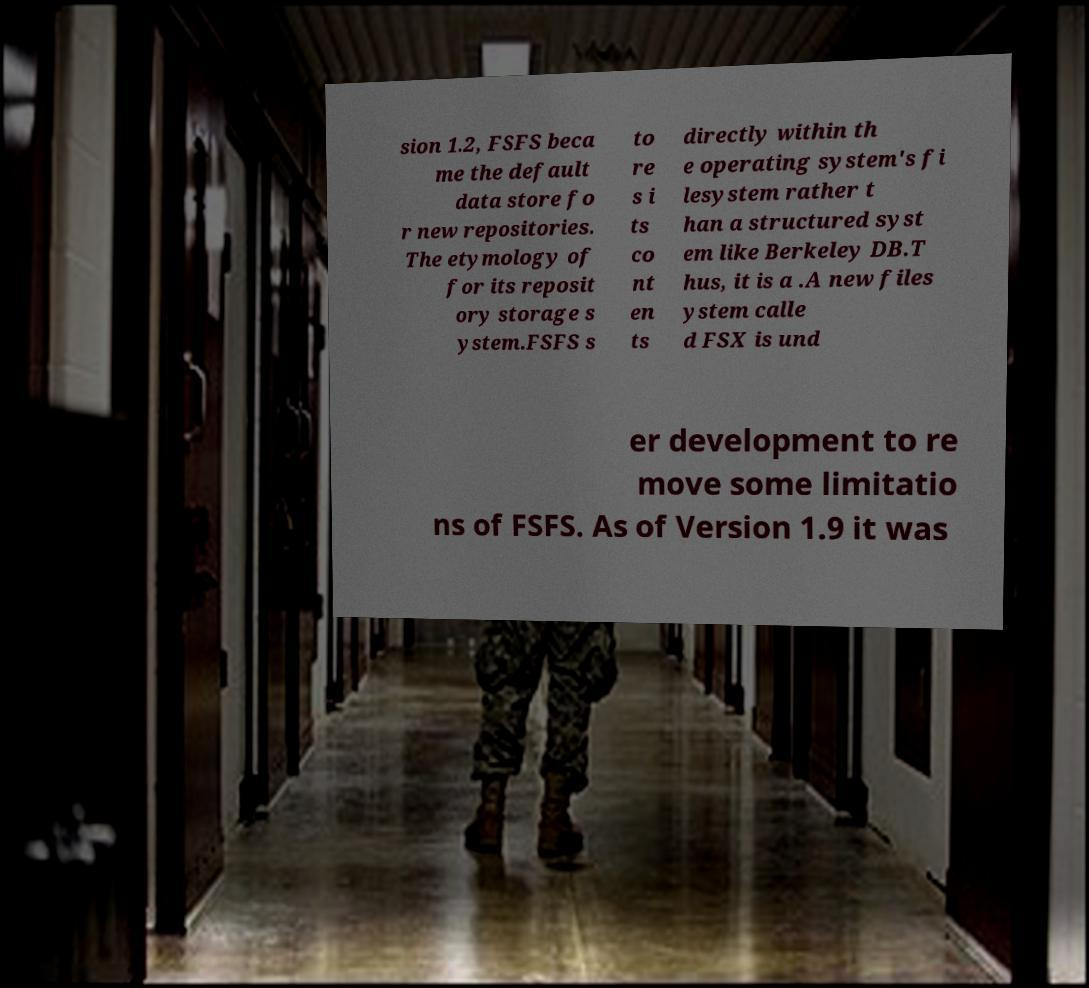What messages or text are displayed in this image? I need them in a readable, typed format. sion 1.2, FSFS beca me the default data store fo r new repositories. The etymology of for its reposit ory storage s ystem.FSFS s to re s i ts co nt en ts directly within th e operating system's fi lesystem rather t han a structured syst em like Berkeley DB.T hus, it is a .A new files ystem calle d FSX is und er development to re move some limitatio ns of FSFS. As of Version 1.9 it was 